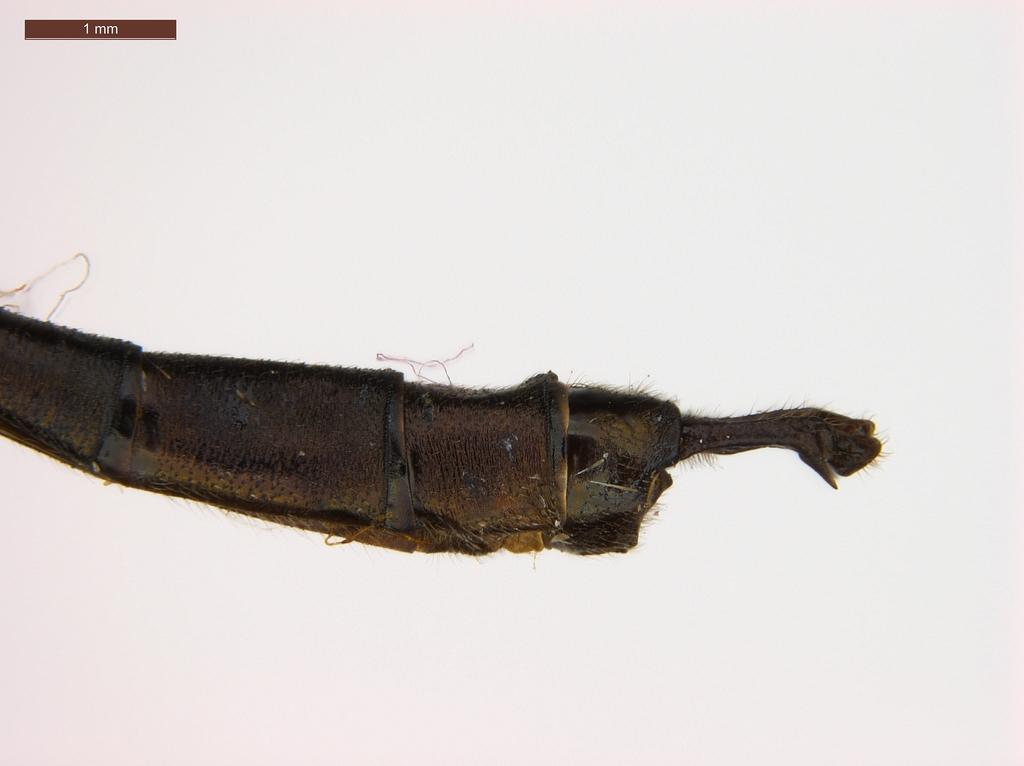What type of animal is in the image? The specific type of animal cannot be determined from the provided facts. What color is the background of the image? The background of the image is white. How many elbows does the animal have in the image? The provided facts do not mention any specific details about the animal's body parts, including elbows. 